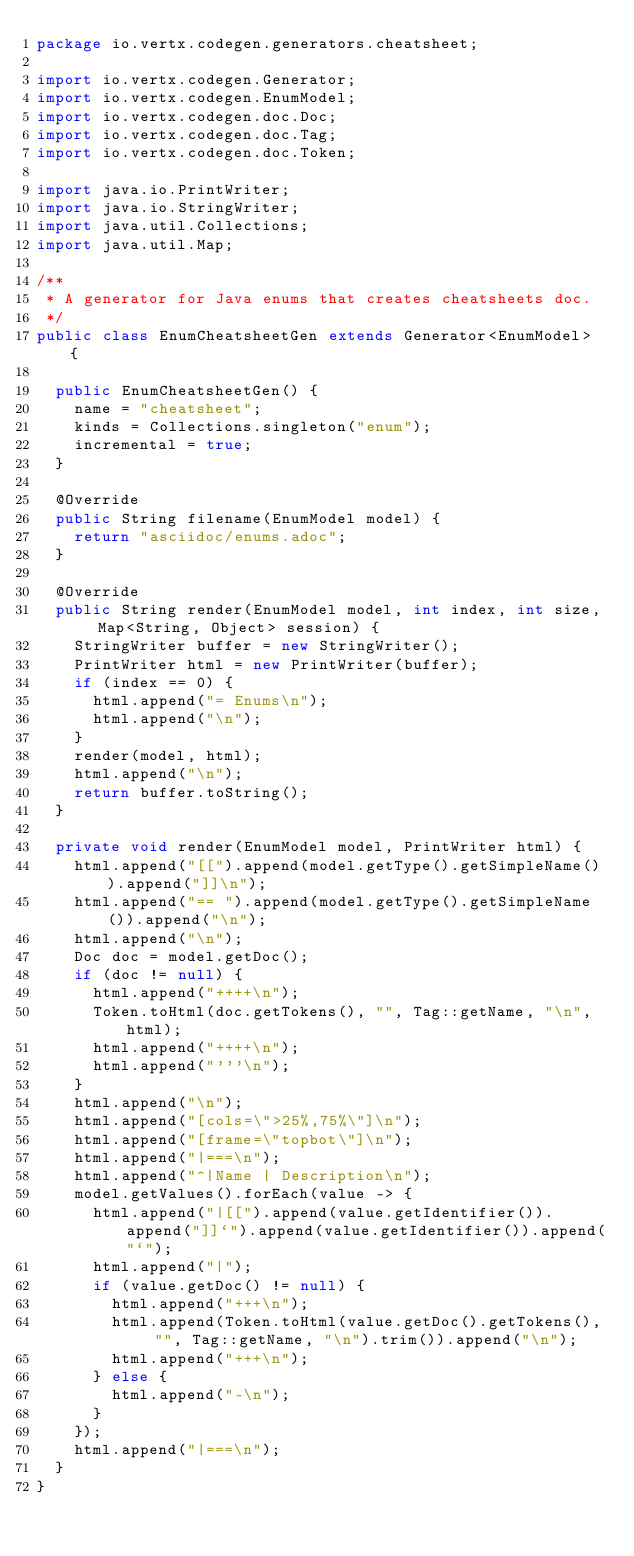<code> <loc_0><loc_0><loc_500><loc_500><_Java_>package io.vertx.codegen.generators.cheatsheet;

import io.vertx.codegen.Generator;
import io.vertx.codegen.EnumModel;
import io.vertx.codegen.doc.Doc;
import io.vertx.codegen.doc.Tag;
import io.vertx.codegen.doc.Token;

import java.io.PrintWriter;
import java.io.StringWriter;
import java.util.Collections;
import java.util.Map;

/**
 * A generator for Java enums that creates cheatsheets doc.
 */
public class EnumCheatsheetGen extends Generator<EnumModel> {

  public EnumCheatsheetGen() {
    name = "cheatsheet";
    kinds = Collections.singleton("enum");
    incremental = true;
  }

  @Override
  public String filename(EnumModel model) {
    return "asciidoc/enums.adoc";
  }

  @Override
  public String render(EnumModel model, int index, int size, Map<String, Object> session) {
    StringWriter buffer = new StringWriter();
    PrintWriter html = new PrintWriter(buffer);
    if (index == 0) {
      html.append("= Enums\n");
      html.append("\n");
    }
    render(model, html);
    html.append("\n");
    return buffer.toString();
  }

  private void render(EnumModel model, PrintWriter html) {
    html.append("[[").append(model.getType().getSimpleName()).append("]]\n");
    html.append("== ").append(model.getType().getSimpleName()).append("\n");
    html.append("\n");
    Doc doc = model.getDoc();
    if (doc != null) {
      html.append("++++\n");
      Token.toHtml(doc.getTokens(), "", Tag::getName, "\n", html);
      html.append("++++\n");
      html.append("'''\n");
    }
    html.append("\n");
    html.append("[cols=\">25%,75%\"]\n");
    html.append("[frame=\"topbot\"]\n");
    html.append("|===\n");
    html.append("^|Name | Description\n");
    model.getValues().forEach(value -> {
      html.append("|[[").append(value.getIdentifier()).append("]]`").append(value.getIdentifier()).append("`");
      html.append("|");
      if (value.getDoc() != null) {
        html.append("+++\n");
        html.append(Token.toHtml(value.getDoc().getTokens(), "", Tag::getName, "\n").trim()).append("\n");
        html.append("+++\n");
      } else {
        html.append("-\n");
      }
    });
    html.append("|===\n");
  }
}
</code> 